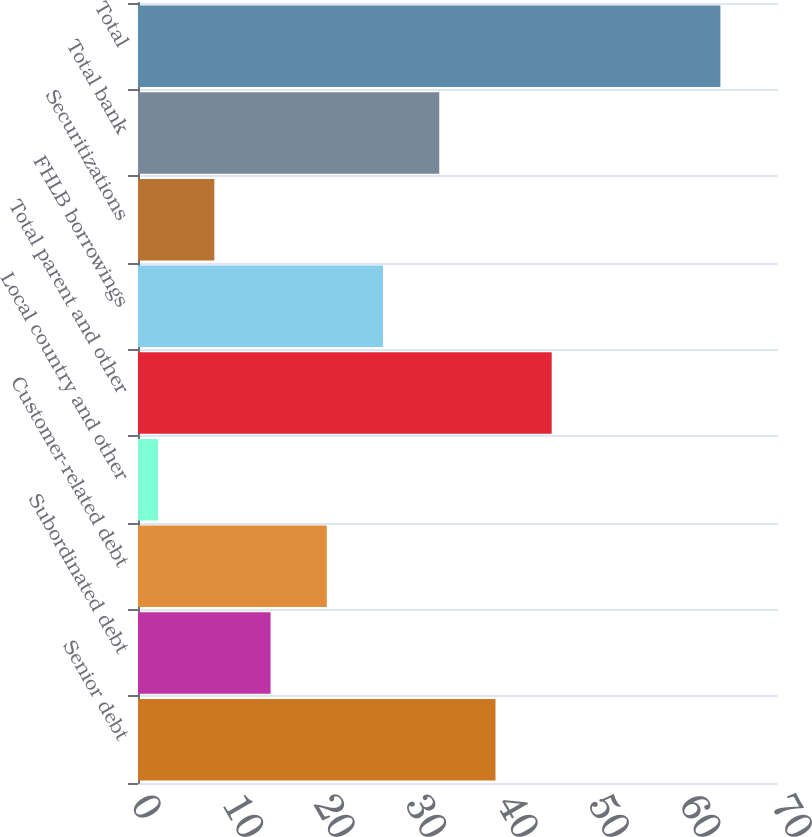Convert chart to OTSL. <chart><loc_0><loc_0><loc_500><loc_500><bar_chart><fcel>Senior debt<fcel>Subordinated debt<fcel>Customer-related debt<fcel>Local country and other<fcel>Total parent and other<fcel>FHLB borrowings<fcel>Securitizations<fcel>Total bank<fcel>Total<nl><fcel>39.1<fcel>14.5<fcel>20.65<fcel>2.2<fcel>45.25<fcel>26.8<fcel>8.35<fcel>32.95<fcel>63.7<nl></chart> 